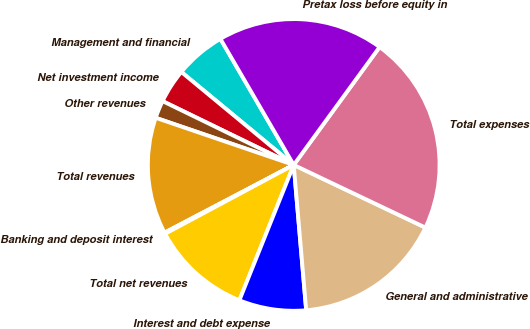Convert chart to OTSL. <chart><loc_0><loc_0><loc_500><loc_500><pie_chart><fcel>Management and financial<fcel>Net investment income<fcel>Other revenues<fcel>Total revenues<fcel>Banking and deposit interest<fcel>Total net revenues<fcel>Interest and debt expense<fcel>General and administrative<fcel>Total expenses<fcel>Pretax loss before equity in<nl><fcel>5.62%<fcel>3.79%<fcel>1.97%<fcel>12.92%<fcel>0.14%<fcel>11.1%<fcel>7.44%<fcel>16.57%<fcel>22.05%<fcel>18.4%<nl></chart> 